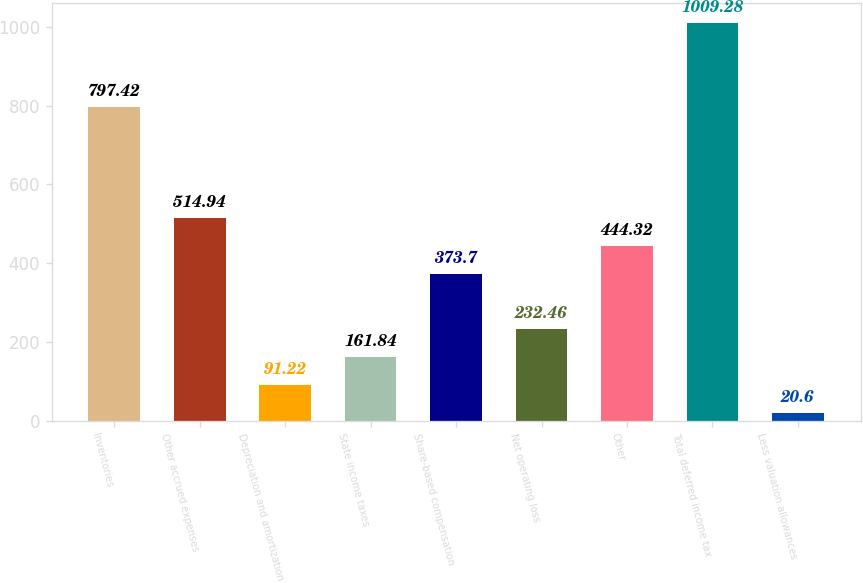Convert chart. <chart><loc_0><loc_0><loc_500><loc_500><bar_chart><fcel>Inventories<fcel>Other accrued expenses<fcel>Depreciation and amortization<fcel>State income taxes<fcel>Share-based compensation<fcel>Net operating loss<fcel>Other<fcel>Total deferred income tax<fcel>Less valuation allowances<nl><fcel>797.42<fcel>514.94<fcel>91.22<fcel>161.84<fcel>373.7<fcel>232.46<fcel>444.32<fcel>1009.28<fcel>20.6<nl></chart> 